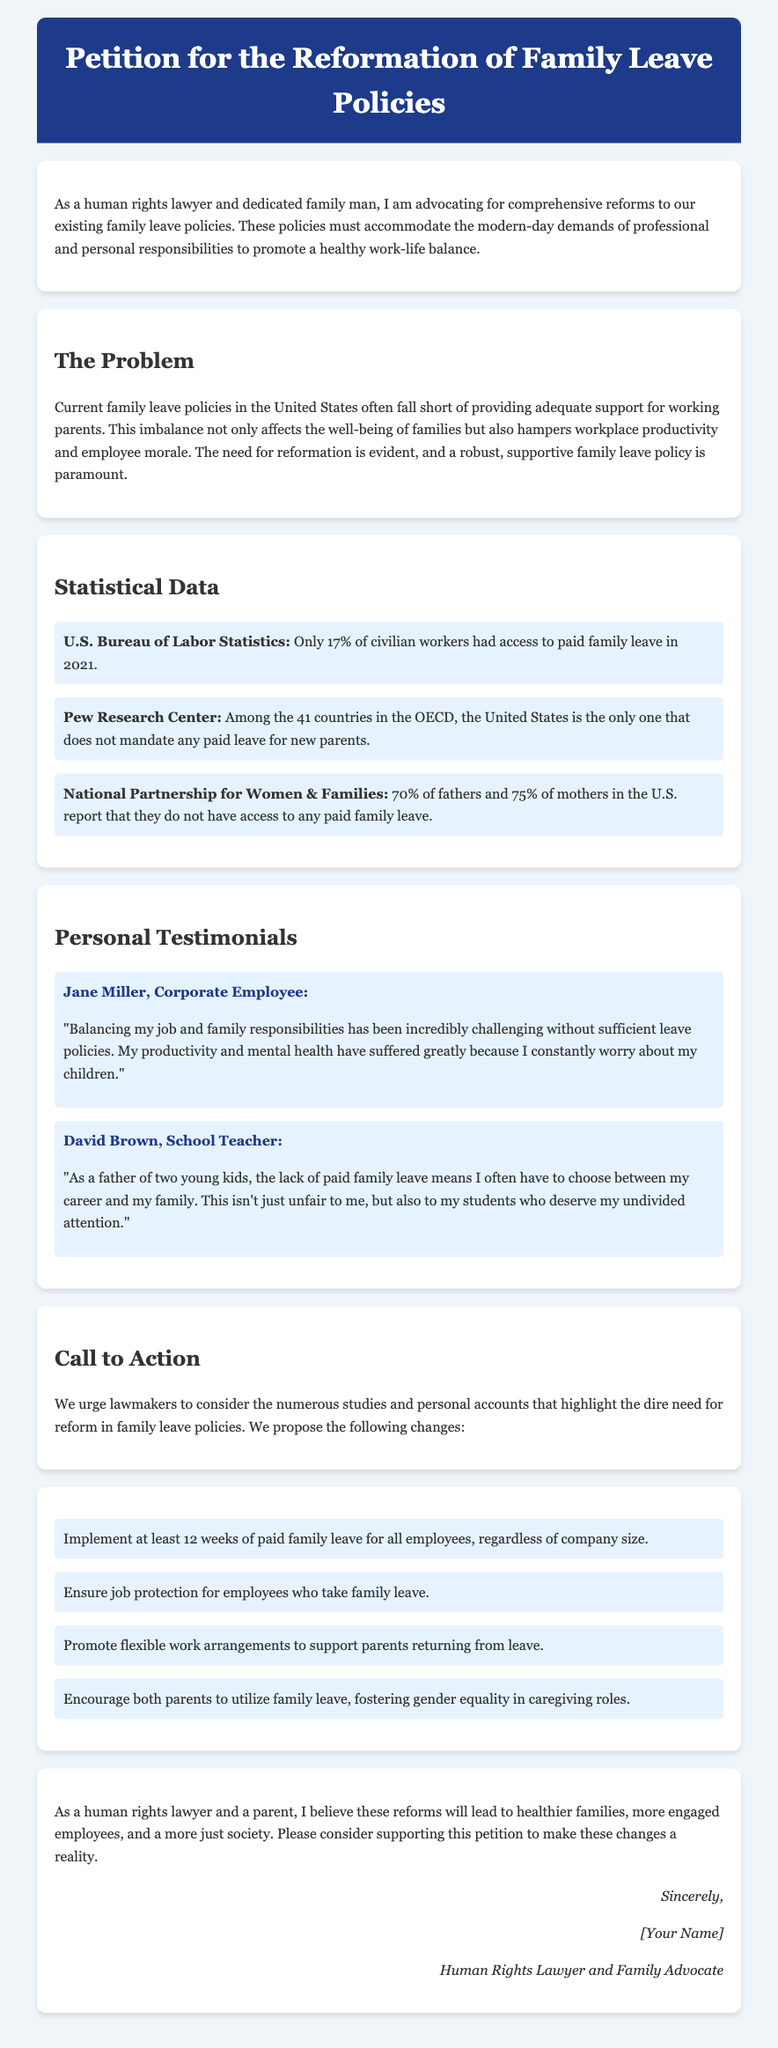What percentage of civilian workers had access to paid family leave in 2021? The U.S. Bureau of Labor Statistics reported that only 17% of civilian workers had access to paid family leave in 2021.
Answer: 17% What is the proposed duration of paid family leave for all employees? The document suggests implementing at least 12 weeks of paid family leave for all employees, regardless of company size.
Answer: 12 weeks Who cited that the United States does not mandate any paid leave for new parents? The Pew Research Center stated that among the 41 countries in the OECD, the United States is the only one that does not mandate any paid leave for new parents.
Answer: Pew Research Center What is a common consequence mentioned in personal testimonials due to lack of leave? Testimonials reveal that parents experience increased stress and decreased productivity due to inadequate family leave policies.
Answer: Increased stress What specific group of parents reported not having access to any paid family leave? According to the National Partnership for Women & Families, 70% of fathers and 75% of mothers in the U.S. reported that they do not have access to any paid family leave.
Answer: Fathers and mothers What type of policies does the petition advocate for? The petition advocates for comprehensive reforms to family leave policies to support work-life balance.
Answer: Comprehensive reforms What is one suggestion made to encourage gender equality in caregiving roles? One proposal in the document encourages both parents to utilize family leave to foster gender equality in caregiving roles.
Answer: Encourage both parents Who is the author of the petition? The petition is authored by a human rights lawyer and family advocate, as stated at the bottom of the document.
Answer: A human rights lawyer and family advocate 